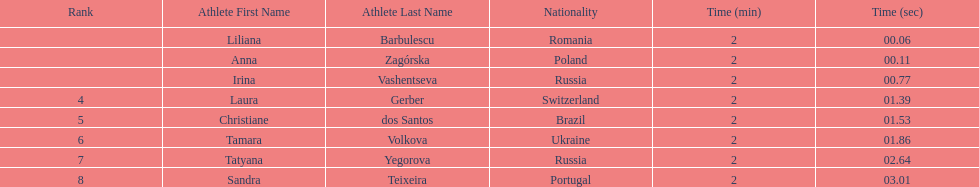In regards to anna zagorska, what was her finishing time? 2:00.11. 